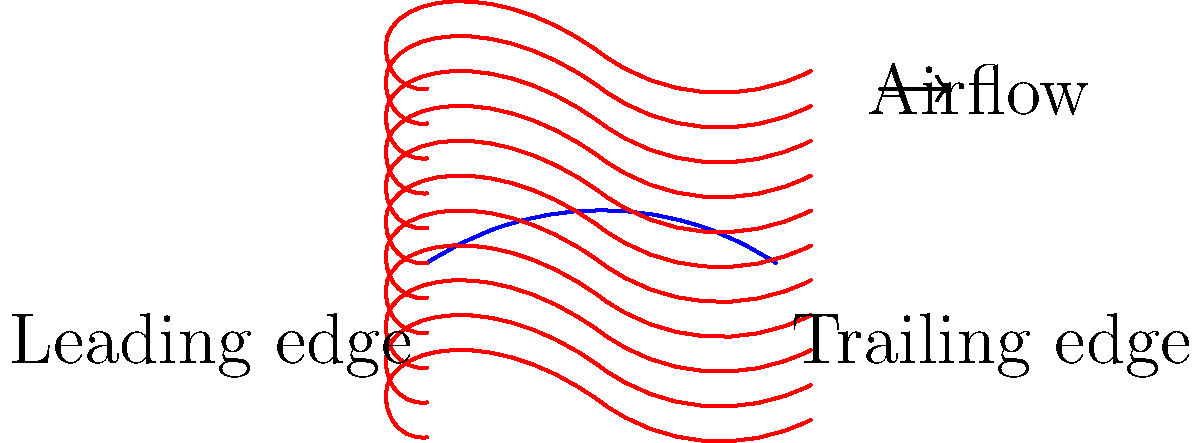In the context of literary analysis using natural language processing, how might the airflow pattern around an airfoil, as shown in the diagram, be analogous to the flow of narrative in a novel? Specifically, consider the concepts of "leading edge" and "trailing edge" in relation to story structure. To answer this question, let's break down the analogy step-by-step:

1. Airfoil shape: In aerodynamics, an airfoil is designed to generate lift. In literature, the overall structure of a novel is designed to generate engagement and meaning.

2. Leading edge: In the airfoil, this is where the air first encounters the shape. In a novel, this could represent the introduction or opening chapters where readers first encounter the story.

3. Streamlines: The lines showing airflow represent how air moves around the airfoil. In a novel, this could represent the flow of narrative, plot points, and character development.

4. Curvature: The airfoil's curved shape alters the airflow. Similarly, the structure of a novel (rising action, climax, falling action) alters the "flow" of the narrative.

5. Trailing edge: In aerodynamics, this is where airflow reunites after splitting around the airfoil. In literature, this could represent the conclusion of the novel, where various plot threads come together.

6. Pressure differences: Though not explicitly shown, airfoils create lift due to pressure differences above and below. In a novel, tension and resolution could be seen as analogous "pressure differences" driving the story forward.

7. Smoothness: The smooth flow of air is crucial for efficiency in aerodynamics. In literature, a smooth narrative flow is often desirable for reader engagement.

Natural Language Processing (NLP) could be used to analyze these aspects of narrative structure, identifying patterns in language use, pacing, and thematic development that correspond to different parts of the "narrative airfoil."
Answer: Narrative flow analysis: introduction (leading edge), plot development (streamlines), conclusion (trailing edge); NLP to identify linguistic patterns corresponding to narrative structure. 